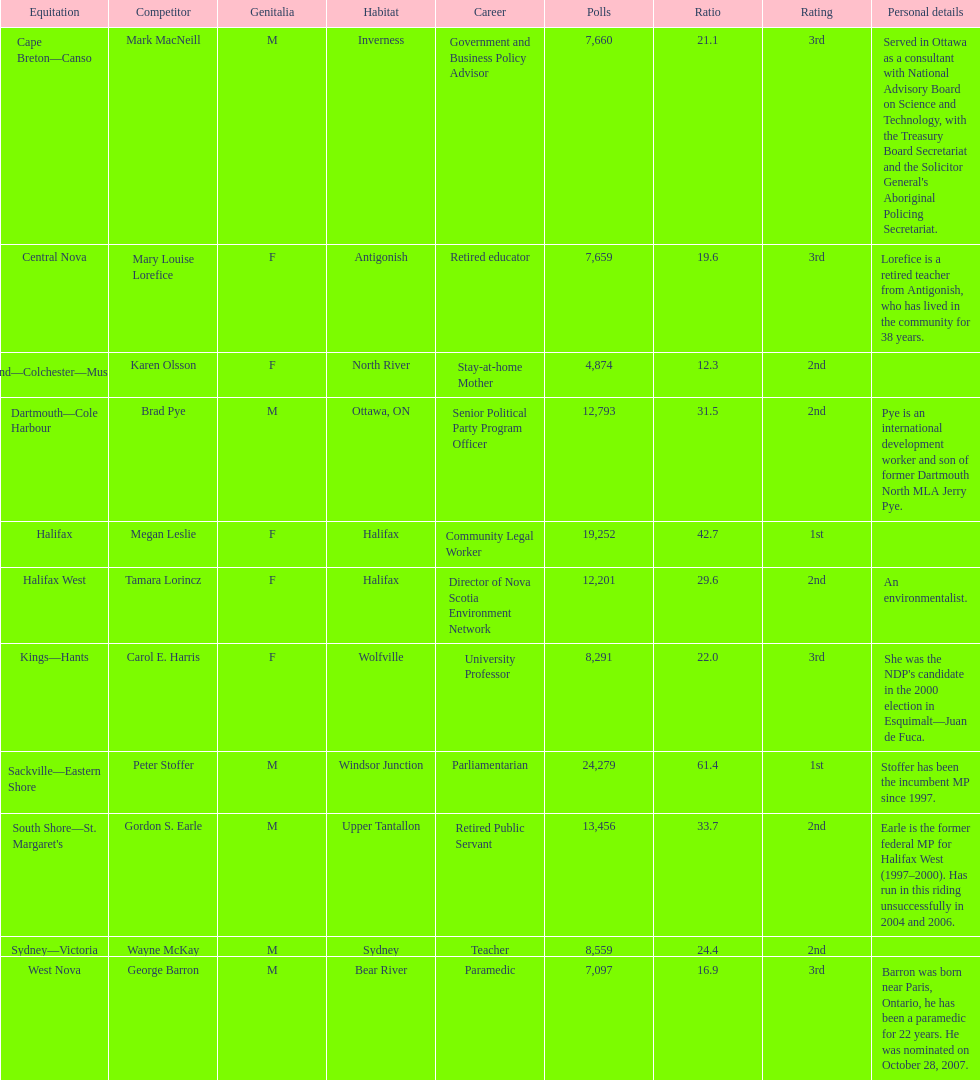Who were all of the new democratic party candidates during the 2008 canadian federal election? Mark MacNeill, Mary Louise Lorefice, Karen Olsson, Brad Pye, Megan Leslie, Tamara Lorincz, Carol E. Harris, Peter Stoffer, Gordon S. Earle, Wayne McKay, George Barron. And between mark macneill and karen olsson, which candidate received more votes? Mark MacNeill. 